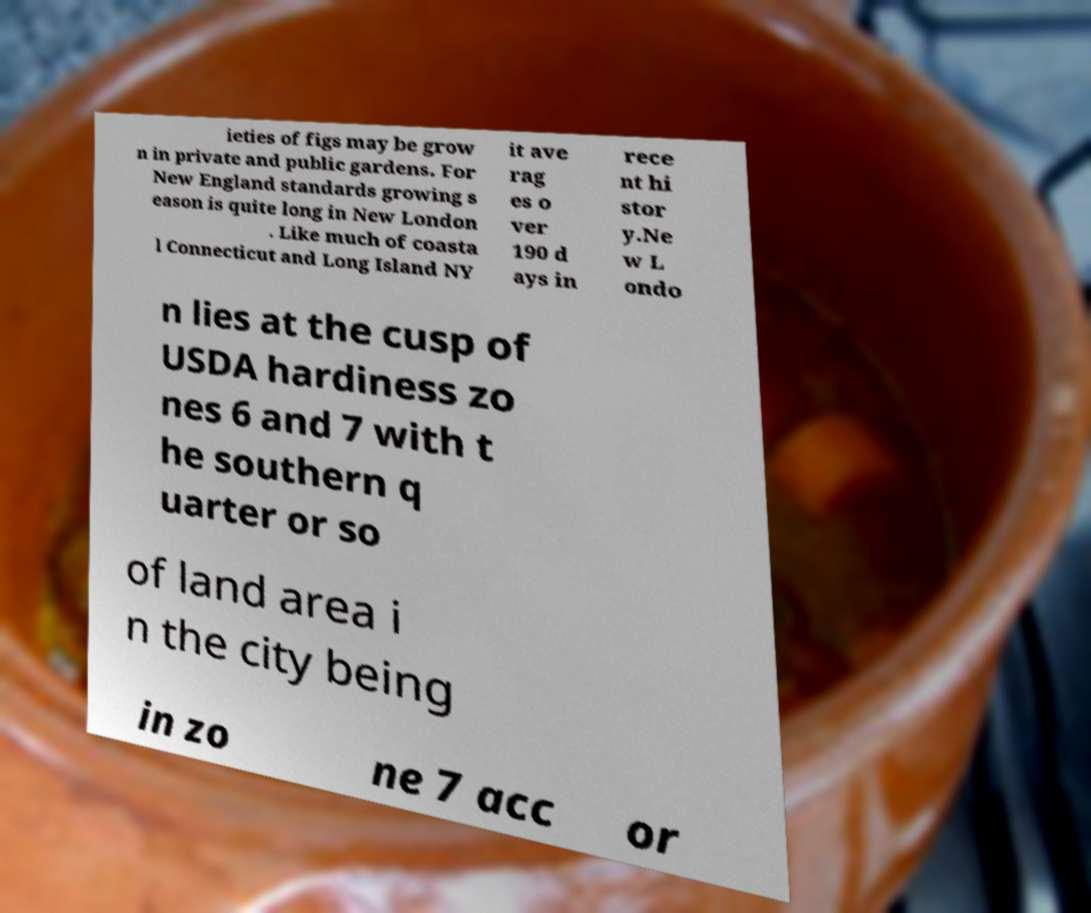What messages or text are displayed in this image? I need them in a readable, typed format. ieties of figs may be grow n in private and public gardens. For New England standards growing s eason is quite long in New London . Like much of coasta l Connecticut and Long Island NY it ave rag es o ver 190 d ays in rece nt hi stor y.Ne w L ondo n lies at the cusp of USDA hardiness zo nes 6 and 7 with t he southern q uarter or so of land area i n the city being in zo ne 7 acc or 